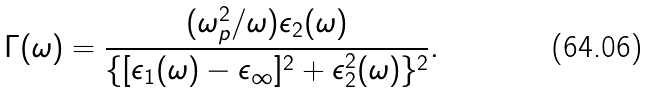<formula> <loc_0><loc_0><loc_500><loc_500>\Gamma ( \omega ) = \frac { ( \omega _ { p } ^ { 2 } / \omega ) \epsilon _ { 2 } ( \omega ) } { \{ [ \epsilon _ { 1 } ( \omega ) - \epsilon _ { \infty } ] ^ { 2 } + \epsilon _ { 2 } ^ { 2 } ( \omega ) \} ^ { 2 } } .</formula> 